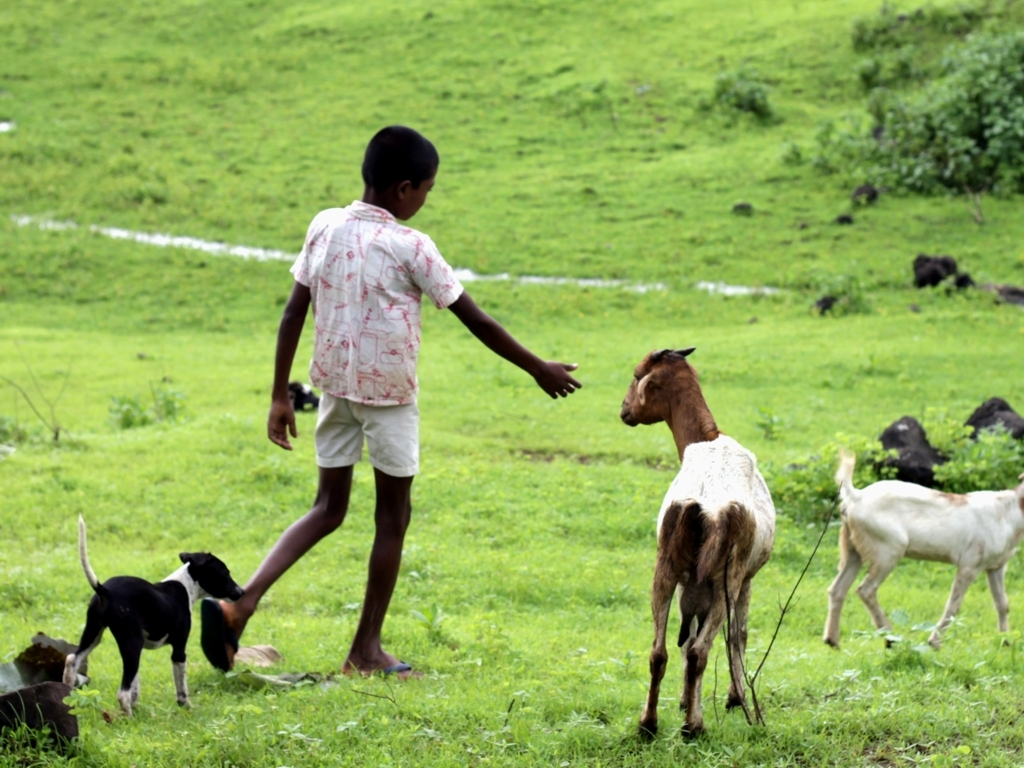What is the child doing in the image? The child appears to be interacting with the goats in the field, possibly playing with them or attempting to guide or feed them. The gesture seems gentle and implies a moment of connection between the child and the animals. Does the image suggest a particular season or time of day? The lush greenery and overcast sky suggest that it might be during the monsoon season. The diffused lighting implies it could be early in the morning or late in the afternoon, a time when the sun's rays are not as harsh. 